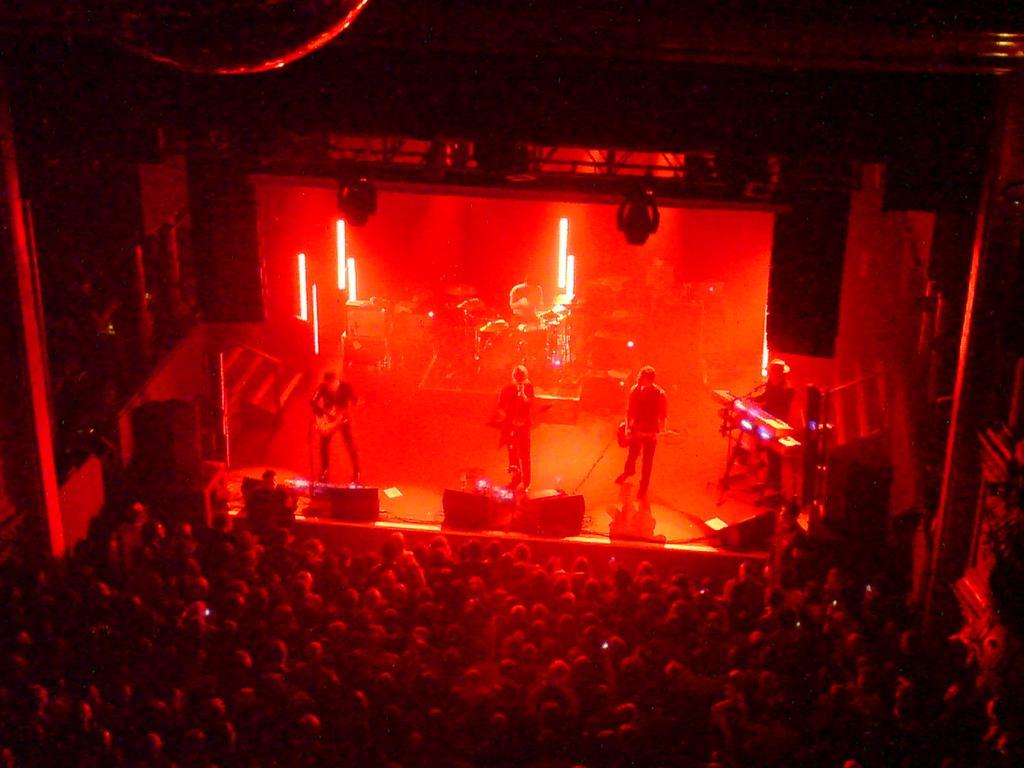Could you give a brief overview of what you see in this image? There is a crowd. Also there is a stage. On the stage there are few people playing musical instruments. There are lights and speakers on the stage. Also there is a keyboard and drums. 